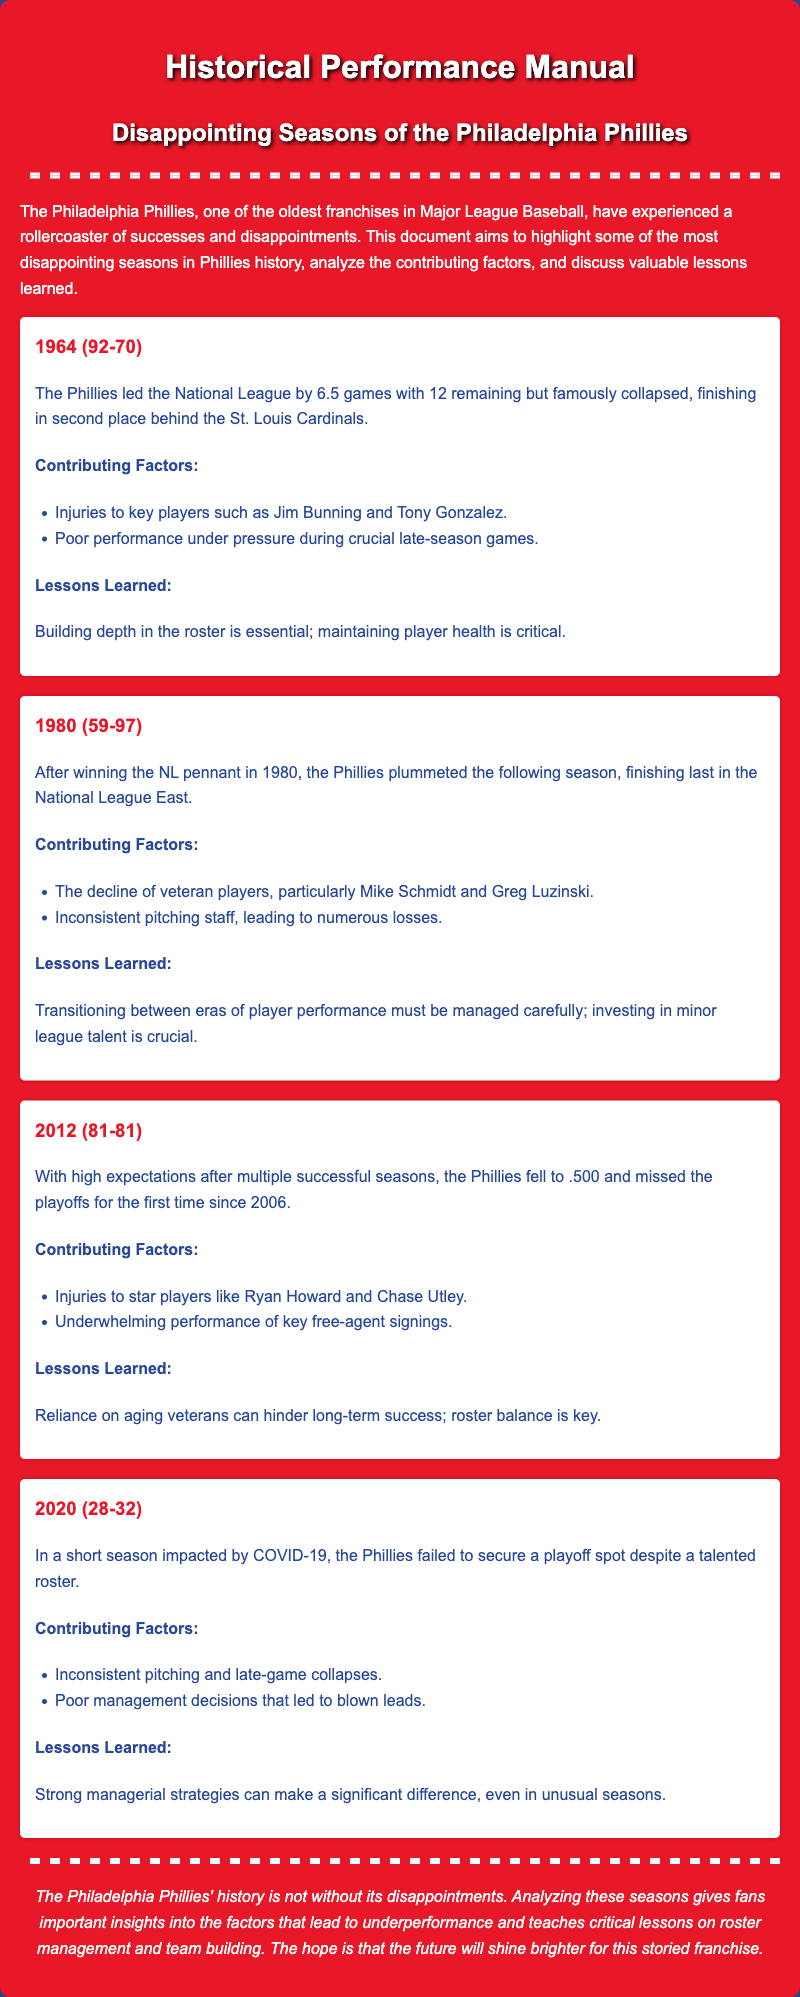What year did the Phillies collapse after leading the National League? The document states that in 1964, the Phillies led the National League by 6.5 games but collapsed.
Answer: 1964 What was the Phillies' win-loss record in 1980? The document provides the performance as 59 wins and 97 losses for the 1980 season.
Answer: 59-97 Which players were injured in 2012? The document mentions injuries to Ryan Howard and Chase Utley as contributing factors for the disappointing season.
Answer: Ryan Howard and Chase Utley In which year did the Phillies fail to secure a playoff spot for the first time since 2006? The document indicates that they fell to .500 in 2012, missing the playoffs for the first time since 2006.
Answer: 2012 What major event impacted the 2020 season? The document notes that the COVID-19 situation had a significant impact on the 2020 season.
Answer: COVID-19 What lesson was learned from the 1964 season? According to the document, a key lesson from the 1964 season was about the importance of building depth in the roster.
Answer: Building depth in the roster What contributed to the Phillies finishing last in the National League East in 1980? The document discusses the decline of veteran players, particularly Mike Schmidt and Greg Luzinski, as a key factor.
Answer: Decline of veteran players What is a noted reason for the Phillies' underperformance in 2020? The document states that inconsistent pitching and late-game collapses were key reasons for their underperformance.
Answer: Inconsistent pitching and late-game collapses 